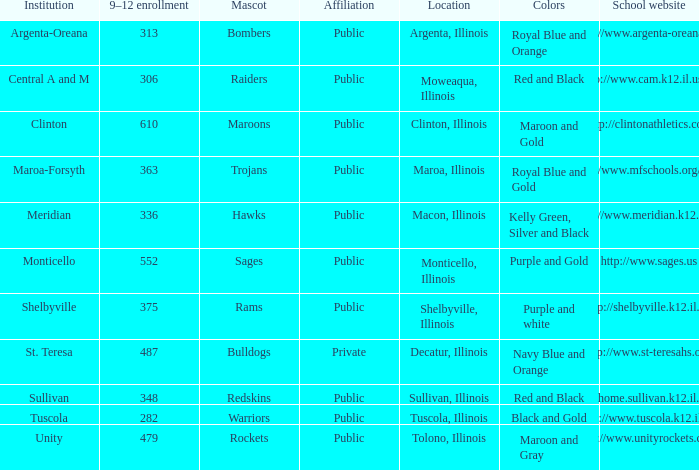How many different combinations of team colors are there in all the schools in Maroa, Illinois? 1.0. 